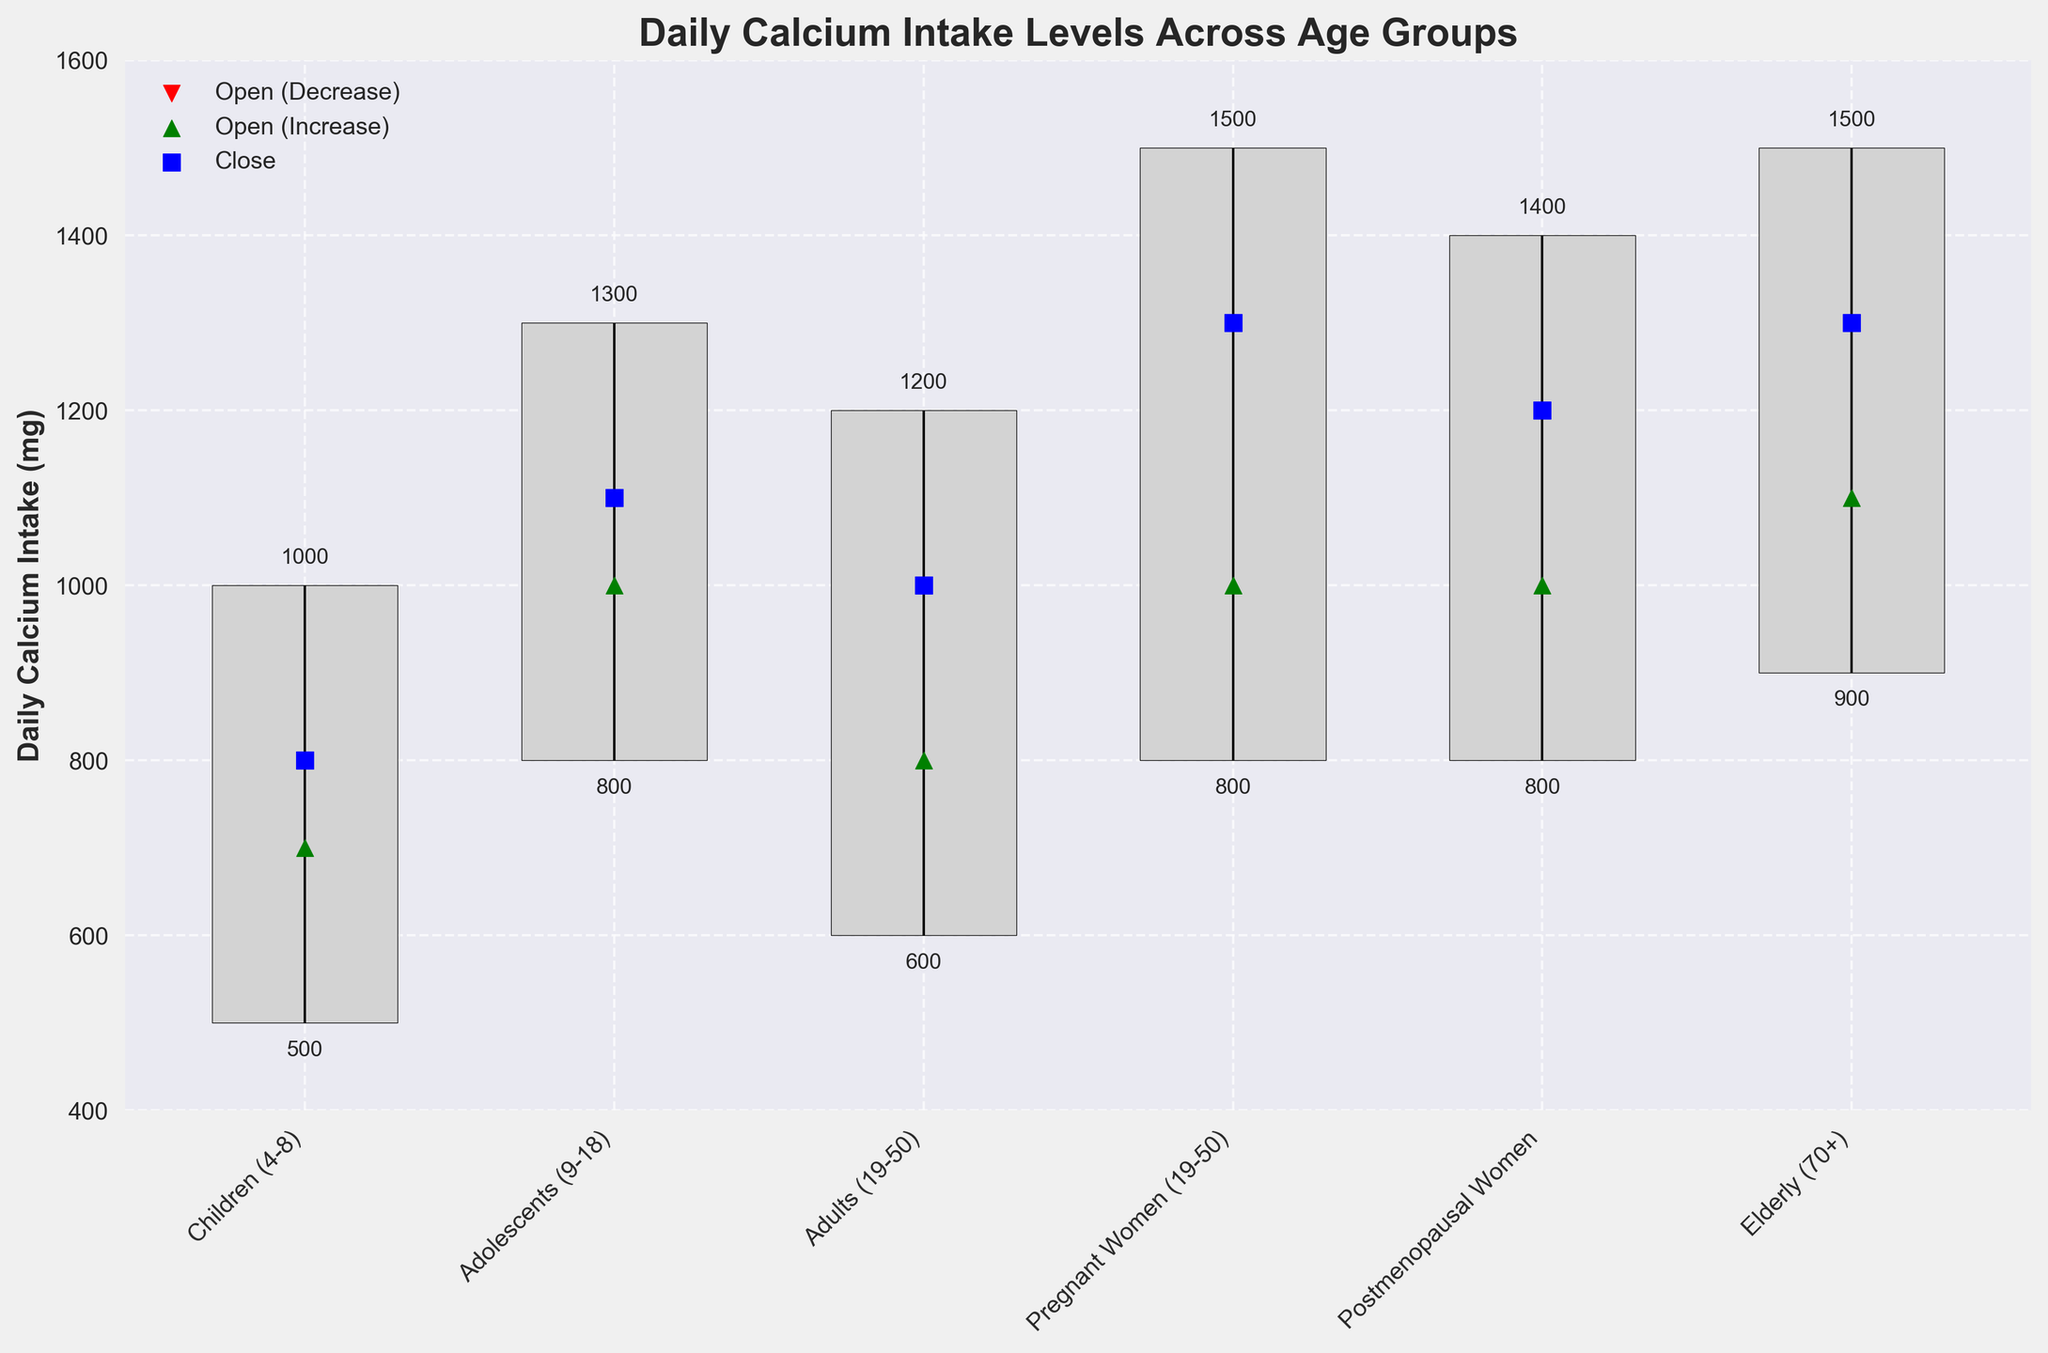What is the title of the chart? The title of the chart is prominently displayed at the top.
Answer: Daily Calcium Intake Levels Across Age Groups Which age group has the highest recorded value for daily calcium intake? Observe the 'High' values for all age groups and identify the maximum value. The highest value of 1500 mg appears for both Pregnant Women (19-50) and Elderly (70+).
Answer: Pregnant Women (19-50) and Elderly (70+) What are the open and close values for Adolescents (9-18)? Look at the points for the Adolescents (9-18) group. The green triangle shows the open value, and the blue square shows the close value. The open value is 1000 mg, and the close value is 1100 mg.
Answer: Open: 1000, Close: 1100 Which age group has the smallest range between high and low values? Calculate the difference between the 'High' and 'Low' values for each age group and compare. Children (4-8) have a range of (1000 - 500) = 500 mg, which is the smallest.
Answer: Children (4-8) Which group opens at a higher value than it closes? Compare the open (green triangle or red triangle) and close (blue square) values for each group. The Children (4-8) group opens at 700 mg and closes at 800 mg, which is higher.
Answer: Children (4-8) What are the high and low values for Postmenopausal Women? Look at the vertical line in the Postmenopausal Women group to find the high and low values. The values are 1400 mg (high) and 800 mg (low).
Answer: High: 1400, Low: 800 Which age groups have an increase from their open to close values? Check where the open value (green or red triangle) is less than the close value (blue square). Adolescents (9-18), Adults (19-50), Pregnant Women (19-50), Postmenopausal Women, and Elderly (70+) all show an increase.
Answer: Adolescents (9-18), Adults (19-50), Pregnant Women (19-50), Postmenopausal Women, Elderly (70+) What is the average close value across all age groups? Add up all close values and divide by the total number of groups (800 + 1100 + 1000 + 1300 + 1200 + 1300) / 6 = 6700 / 6 ≈ 1117 mg
Answer: 1117 Which group has the highest opening value and what is that value? Compare the open values (green or red triangles) of all groups. The highest opening value is 1100 mg for the Elderly (70+).
Answer: Elderly (70+), Open: 1100 How does the low value for Adults (19-50) compare with the high value for Children (4-8)? Compare Adults (19-50) low value of 600 mg with Children (4-8) high value of 1000 mg. The low value for Adults is 400 mg less than the high value for Children.
Answer: 400 mg less 